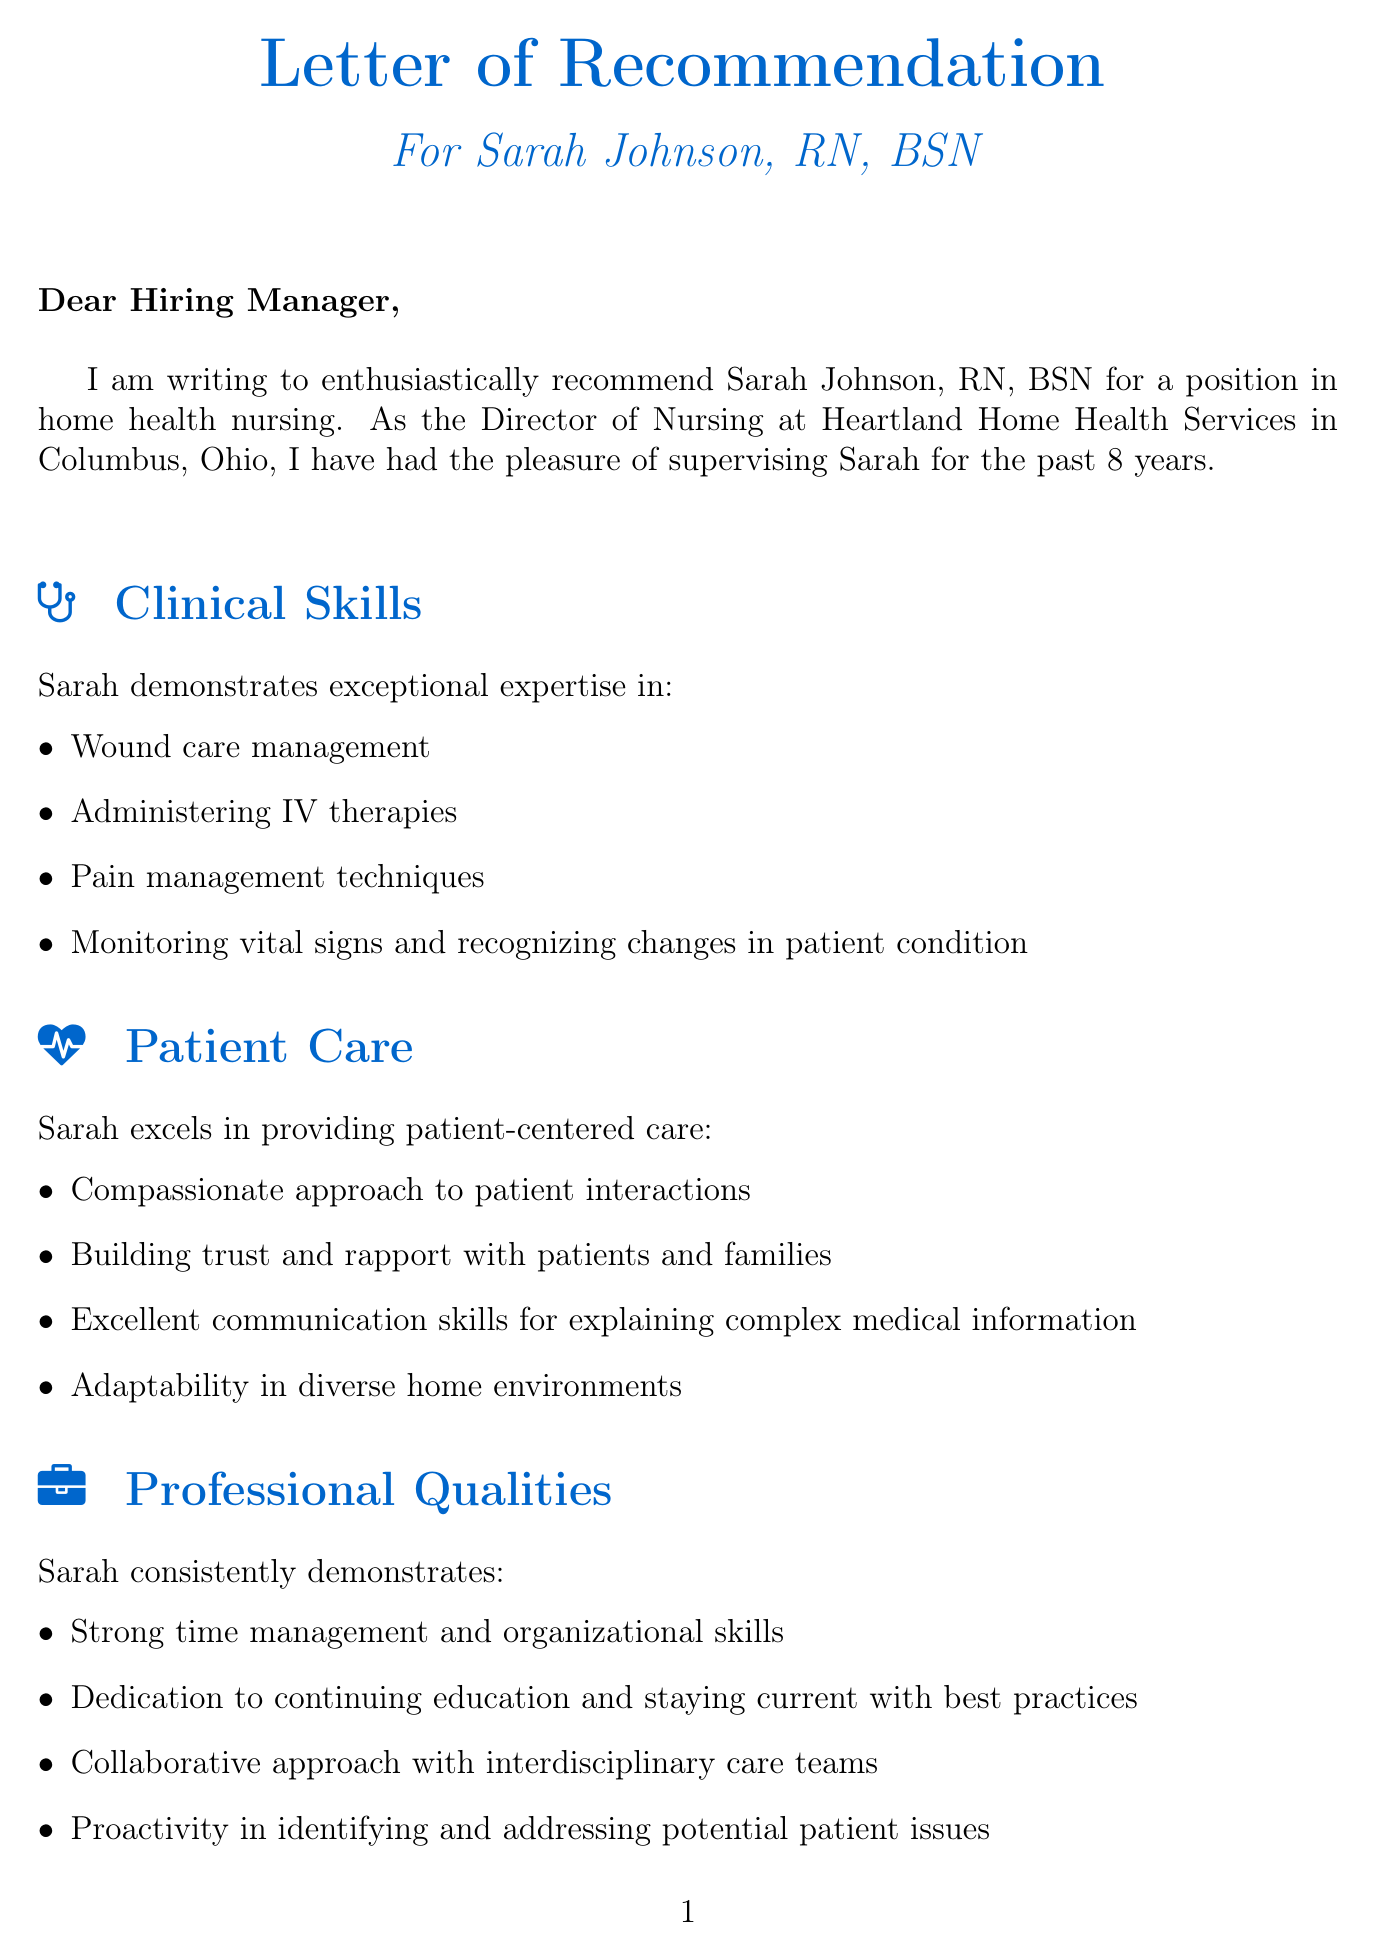What is the name of the nurse being recommended? The document explicitly states that the nurse being recommended is Sarah Johnson, RN, BSN.
Answer: Sarah Johnson, RN, BSN How many years of experience does Sarah have? The letter mentions that Sarah has 8 years of experience in home health nursing.
Answer: 8 What is the position of the writer? The document indicates that the writer holds the position of Director of Nursing.
Answer: Director of Nursing Which company does Sarah work for? The letter specifies that Sarah works for Heartland Home Health Services.
Answer: Heartland Home Health Services What is one of Sarah's certifications? The document lists her certifications including Certified Wound Care Nurse (CWCN).
Answer: Certified Wound Care Nurse (CWCN) What type of patient population does Heartland Home Health Services primarily serve? The letter states that Heartland primarily serves elderly and post-acute care patients.
Answer: Primarily elderly and post-acute care patients What is one example of Sarah's clinical skills? The document lists wound care management as one of her clinical skills.
Answer: Wound care management What was the outcome of the comprehensive care plan developed by Sarah? The document indicates that the comprehensive care plan improved the patient's quality of life and reduced hospital readmissions.
Answer: Improved quality of life and reduced hospital readmissions Why does the writer give a high recommendation to Sarah? The document states that Sarah's exceptional performance and dedication to patient care make her an ideal candidate.
Answer: Exceptional performance and dedication to patient care 